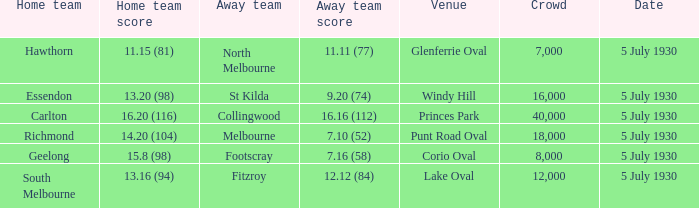Who is the guest team playing at corio oval? Footscray. 